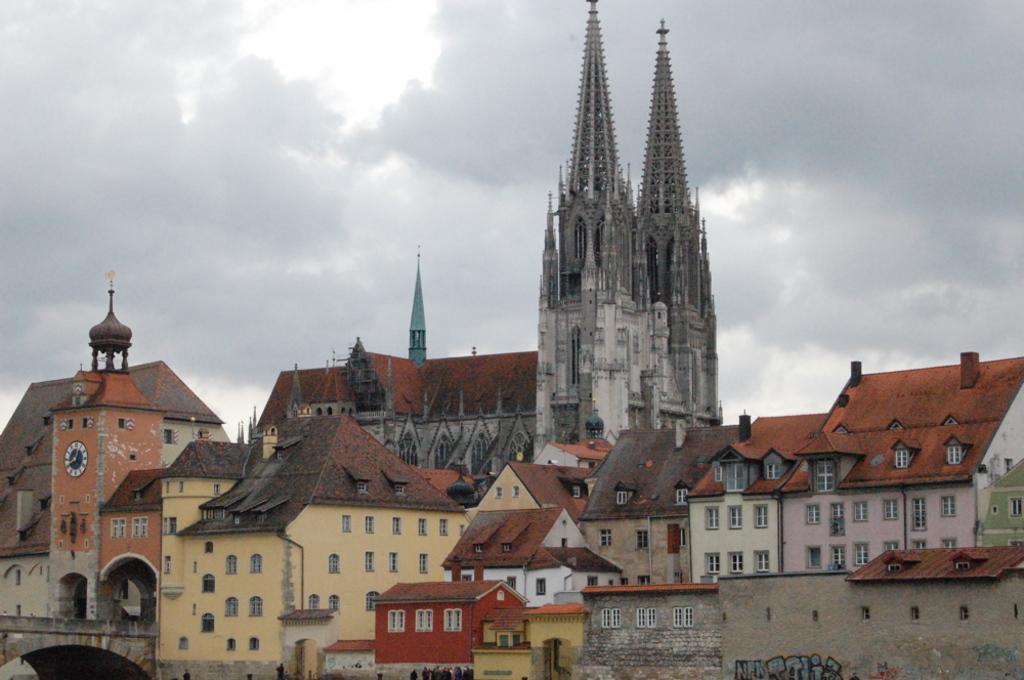In one or two sentences, can you explain what this image depicts? These are the buildings and houses with windows. This looks like a clock tower with a clock attached to it. I think this is a bridge. I can see the spires, which are at the top of the buildings. These are the clouds in the sky. 